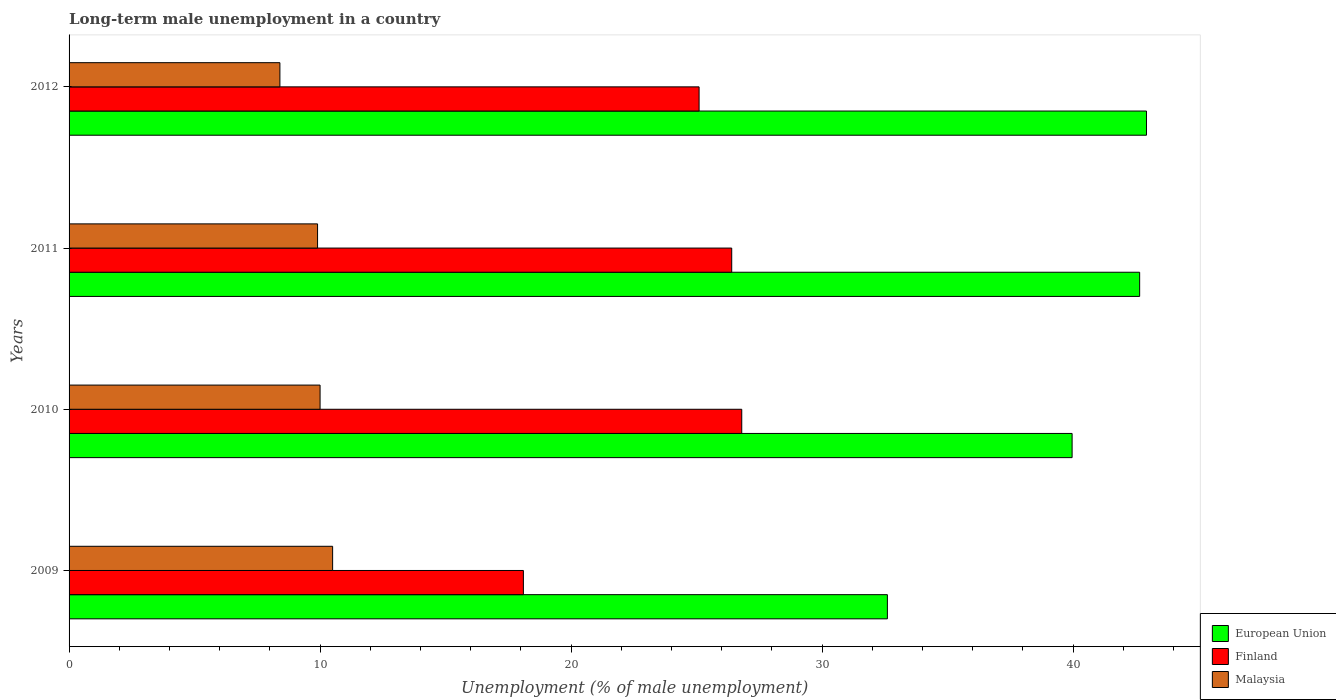How many groups of bars are there?
Ensure brevity in your answer.  4. How many bars are there on the 4th tick from the bottom?
Keep it short and to the point. 3. What is the label of the 2nd group of bars from the top?
Your response must be concise. 2011. What is the percentage of long-term unemployed male population in Finland in 2010?
Your answer should be compact. 26.8. Across all years, what is the maximum percentage of long-term unemployed male population in European Union?
Offer a terse response. 42.92. Across all years, what is the minimum percentage of long-term unemployed male population in European Union?
Ensure brevity in your answer.  32.6. In which year was the percentage of long-term unemployed male population in Finland minimum?
Ensure brevity in your answer.  2009. What is the total percentage of long-term unemployed male population in European Union in the graph?
Give a very brief answer. 158.14. What is the difference between the percentage of long-term unemployed male population in European Union in 2010 and that in 2012?
Keep it short and to the point. -2.96. What is the difference between the percentage of long-term unemployed male population in European Union in 2011 and the percentage of long-term unemployed male population in Malaysia in 2012?
Keep it short and to the point. 34.25. What is the average percentage of long-term unemployed male population in Malaysia per year?
Your answer should be very brief. 9.7. In the year 2010, what is the difference between the percentage of long-term unemployed male population in Finland and percentage of long-term unemployed male population in European Union?
Your answer should be compact. -13.16. In how many years, is the percentage of long-term unemployed male population in Finland greater than 6 %?
Your response must be concise. 4. What is the ratio of the percentage of long-term unemployed male population in Malaysia in 2009 to that in 2012?
Provide a succinct answer. 1.25. What is the difference between the highest and the second highest percentage of long-term unemployed male population in Finland?
Your answer should be compact. 0.4. What is the difference between the highest and the lowest percentage of long-term unemployed male population in European Union?
Your response must be concise. 10.32. In how many years, is the percentage of long-term unemployed male population in Finland greater than the average percentage of long-term unemployed male population in Finland taken over all years?
Give a very brief answer. 3. Is the sum of the percentage of long-term unemployed male population in European Union in 2009 and 2011 greater than the maximum percentage of long-term unemployed male population in Malaysia across all years?
Your response must be concise. Yes. What does the 1st bar from the top in 2012 represents?
Make the answer very short. Malaysia. How many bars are there?
Your answer should be compact. 12. How many years are there in the graph?
Provide a short and direct response. 4. Does the graph contain any zero values?
Make the answer very short. No. Does the graph contain grids?
Your answer should be compact. No. How many legend labels are there?
Your response must be concise. 3. What is the title of the graph?
Your answer should be very brief. Long-term male unemployment in a country. What is the label or title of the X-axis?
Make the answer very short. Unemployment (% of male unemployment). What is the label or title of the Y-axis?
Offer a terse response. Years. What is the Unemployment (% of male unemployment) of European Union in 2009?
Provide a succinct answer. 32.6. What is the Unemployment (% of male unemployment) in Finland in 2009?
Offer a terse response. 18.1. What is the Unemployment (% of male unemployment) in European Union in 2010?
Your answer should be very brief. 39.96. What is the Unemployment (% of male unemployment) in Finland in 2010?
Make the answer very short. 26.8. What is the Unemployment (% of male unemployment) in Malaysia in 2010?
Provide a short and direct response. 10. What is the Unemployment (% of male unemployment) of European Union in 2011?
Your response must be concise. 42.65. What is the Unemployment (% of male unemployment) of Finland in 2011?
Ensure brevity in your answer.  26.4. What is the Unemployment (% of male unemployment) in Malaysia in 2011?
Provide a short and direct response. 9.9. What is the Unemployment (% of male unemployment) of European Union in 2012?
Ensure brevity in your answer.  42.92. What is the Unemployment (% of male unemployment) of Finland in 2012?
Ensure brevity in your answer.  25.1. What is the Unemployment (% of male unemployment) of Malaysia in 2012?
Your response must be concise. 8.4. Across all years, what is the maximum Unemployment (% of male unemployment) in European Union?
Offer a very short reply. 42.92. Across all years, what is the maximum Unemployment (% of male unemployment) in Finland?
Provide a short and direct response. 26.8. Across all years, what is the minimum Unemployment (% of male unemployment) of European Union?
Give a very brief answer. 32.6. Across all years, what is the minimum Unemployment (% of male unemployment) in Finland?
Provide a short and direct response. 18.1. Across all years, what is the minimum Unemployment (% of male unemployment) in Malaysia?
Offer a very short reply. 8.4. What is the total Unemployment (% of male unemployment) in European Union in the graph?
Your answer should be very brief. 158.14. What is the total Unemployment (% of male unemployment) in Finland in the graph?
Provide a succinct answer. 96.4. What is the total Unemployment (% of male unemployment) of Malaysia in the graph?
Your answer should be very brief. 38.8. What is the difference between the Unemployment (% of male unemployment) in European Union in 2009 and that in 2010?
Your answer should be very brief. -7.36. What is the difference between the Unemployment (% of male unemployment) of Malaysia in 2009 and that in 2010?
Offer a very short reply. 0.5. What is the difference between the Unemployment (% of male unemployment) of European Union in 2009 and that in 2011?
Your answer should be very brief. -10.05. What is the difference between the Unemployment (% of male unemployment) of Malaysia in 2009 and that in 2011?
Ensure brevity in your answer.  0.6. What is the difference between the Unemployment (% of male unemployment) in European Union in 2009 and that in 2012?
Make the answer very short. -10.32. What is the difference between the Unemployment (% of male unemployment) of Malaysia in 2009 and that in 2012?
Provide a succinct answer. 2.1. What is the difference between the Unemployment (% of male unemployment) of European Union in 2010 and that in 2011?
Keep it short and to the point. -2.69. What is the difference between the Unemployment (% of male unemployment) of Finland in 2010 and that in 2011?
Provide a succinct answer. 0.4. What is the difference between the Unemployment (% of male unemployment) of European Union in 2010 and that in 2012?
Make the answer very short. -2.96. What is the difference between the Unemployment (% of male unemployment) of European Union in 2011 and that in 2012?
Offer a terse response. -0.27. What is the difference between the Unemployment (% of male unemployment) of European Union in 2009 and the Unemployment (% of male unemployment) of Finland in 2010?
Your response must be concise. 5.8. What is the difference between the Unemployment (% of male unemployment) in European Union in 2009 and the Unemployment (% of male unemployment) in Malaysia in 2010?
Make the answer very short. 22.6. What is the difference between the Unemployment (% of male unemployment) of Finland in 2009 and the Unemployment (% of male unemployment) of Malaysia in 2010?
Provide a short and direct response. 8.1. What is the difference between the Unemployment (% of male unemployment) of European Union in 2009 and the Unemployment (% of male unemployment) of Finland in 2011?
Your response must be concise. 6.2. What is the difference between the Unemployment (% of male unemployment) in European Union in 2009 and the Unemployment (% of male unemployment) in Malaysia in 2011?
Ensure brevity in your answer.  22.7. What is the difference between the Unemployment (% of male unemployment) in European Union in 2009 and the Unemployment (% of male unemployment) in Finland in 2012?
Your answer should be compact. 7.5. What is the difference between the Unemployment (% of male unemployment) of European Union in 2009 and the Unemployment (% of male unemployment) of Malaysia in 2012?
Provide a short and direct response. 24.2. What is the difference between the Unemployment (% of male unemployment) in European Union in 2010 and the Unemployment (% of male unemployment) in Finland in 2011?
Provide a short and direct response. 13.56. What is the difference between the Unemployment (% of male unemployment) in European Union in 2010 and the Unemployment (% of male unemployment) in Malaysia in 2011?
Offer a terse response. 30.06. What is the difference between the Unemployment (% of male unemployment) in European Union in 2010 and the Unemployment (% of male unemployment) in Finland in 2012?
Provide a succinct answer. 14.86. What is the difference between the Unemployment (% of male unemployment) in European Union in 2010 and the Unemployment (% of male unemployment) in Malaysia in 2012?
Give a very brief answer. 31.56. What is the difference between the Unemployment (% of male unemployment) of Finland in 2010 and the Unemployment (% of male unemployment) of Malaysia in 2012?
Offer a terse response. 18.4. What is the difference between the Unemployment (% of male unemployment) in European Union in 2011 and the Unemployment (% of male unemployment) in Finland in 2012?
Your response must be concise. 17.55. What is the difference between the Unemployment (% of male unemployment) in European Union in 2011 and the Unemployment (% of male unemployment) in Malaysia in 2012?
Offer a very short reply. 34.25. What is the average Unemployment (% of male unemployment) of European Union per year?
Offer a very short reply. 39.54. What is the average Unemployment (% of male unemployment) in Finland per year?
Offer a very short reply. 24.1. What is the average Unemployment (% of male unemployment) of Malaysia per year?
Offer a very short reply. 9.7. In the year 2009, what is the difference between the Unemployment (% of male unemployment) of European Union and Unemployment (% of male unemployment) of Finland?
Offer a very short reply. 14.5. In the year 2009, what is the difference between the Unemployment (% of male unemployment) in European Union and Unemployment (% of male unemployment) in Malaysia?
Provide a succinct answer. 22.1. In the year 2009, what is the difference between the Unemployment (% of male unemployment) of Finland and Unemployment (% of male unemployment) of Malaysia?
Your response must be concise. 7.6. In the year 2010, what is the difference between the Unemployment (% of male unemployment) in European Union and Unemployment (% of male unemployment) in Finland?
Offer a terse response. 13.16. In the year 2010, what is the difference between the Unemployment (% of male unemployment) of European Union and Unemployment (% of male unemployment) of Malaysia?
Make the answer very short. 29.96. In the year 2010, what is the difference between the Unemployment (% of male unemployment) in Finland and Unemployment (% of male unemployment) in Malaysia?
Offer a terse response. 16.8. In the year 2011, what is the difference between the Unemployment (% of male unemployment) of European Union and Unemployment (% of male unemployment) of Finland?
Keep it short and to the point. 16.25. In the year 2011, what is the difference between the Unemployment (% of male unemployment) in European Union and Unemployment (% of male unemployment) in Malaysia?
Provide a succinct answer. 32.75. In the year 2012, what is the difference between the Unemployment (% of male unemployment) in European Union and Unemployment (% of male unemployment) in Finland?
Keep it short and to the point. 17.82. In the year 2012, what is the difference between the Unemployment (% of male unemployment) in European Union and Unemployment (% of male unemployment) in Malaysia?
Provide a short and direct response. 34.52. What is the ratio of the Unemployment (% of male unemployment) of European Union in 2009 to that in 2010?
Provide a succinct answer. 0.82. What is the ratio of the Unemployment (% of male unemployment) in Finland in 2009 to that in 2010?
Give a very brief answer. 0.68. What is the ratio of the Unemployment (% of male unemployment) in Malaysia in 2009 to that in 2010?
Offer a very short reply. 1.05. What is the ratio of the Unemployment (% of male unemployment) in European Union in 2009 to that in 2011?
Make the answer very short. 0.76. What is the ratio of the Unemployment (% of male unemployment) of Finland in 2009 to that in 2011?
Your response must be concise. 0.69. What is the ratio of the Unemployment (% of male unemployment) of Malaysia in 2009 to that in 2011?
Offer a very short reply. 1.06. What is the ratio of the Unemployment (% of male unemployment) of European Union in 2009 to that in 2012?
Your answer should be compact. 0.76. What is the ratio of the Unemployment (% of male unemployment) of Finland in 2009 to that in 2012?
Your answer should be very brief. 0.72. What is the ratio of the Unemployment (% of male unemployment) in Malaysia in 2009 to that in 2012?
Offer a very short reply. 1.25. What is the ratio of the Unemployment (% of male unemployment) in European Union in 2010 to that in 2011?
Offer a very short reply. 0.94. What is the ratio of the Unemployment (% of male unemployment) in Finland in 2010 to that in 2011?
Your answer should be compact. 1.02. What is the ratio of the Unemployment (% of male unemployment) in Malaysia in 2010 to that in 2011?
Provide a succinct answer. 1.01. What is the ratio of the Unemployment (% of male unemployment) in European Union in 2010 to that in 2012?
Offer a very short reply. 0.93. What is the ratio of the Unemployment (% of male unemployment) in Finland in 2010 to that in 2012?
Offer a terse response. 1.07. What is the ratio of the Unemployment (% of male unemployment) in Malaysia in 2010 to that in 2012?
Your answer should be very brief. 1.19. What is the ratio of the Unemployment (% of male unemployment) in Finland in 2011 to that in 2012?
Offer a very short reply. 1.05. What is the ratio of the Unemployment (% of male unemployment) of Malaysia in 2011 to that in 2012?
Provide a succinct answer. 1.18. What is the difference between the highest and the second highest Unemployment (% of male unemployment) of European Union?
Keep it short and to the point. 0.27. What is the difference between the highest and the second highest Unemployment (% of male unemployment) in Finland?
Give a very brief answer. 0.4. What is the difference between the highest and the lowest Unemployment (% of male unemployment) of European Union?
Make the answer very short. 10.32. What is the difference between the highest and the lowest Unemployment (% of male unemployment) in Finland?
Make the answer very short. 8.7. 